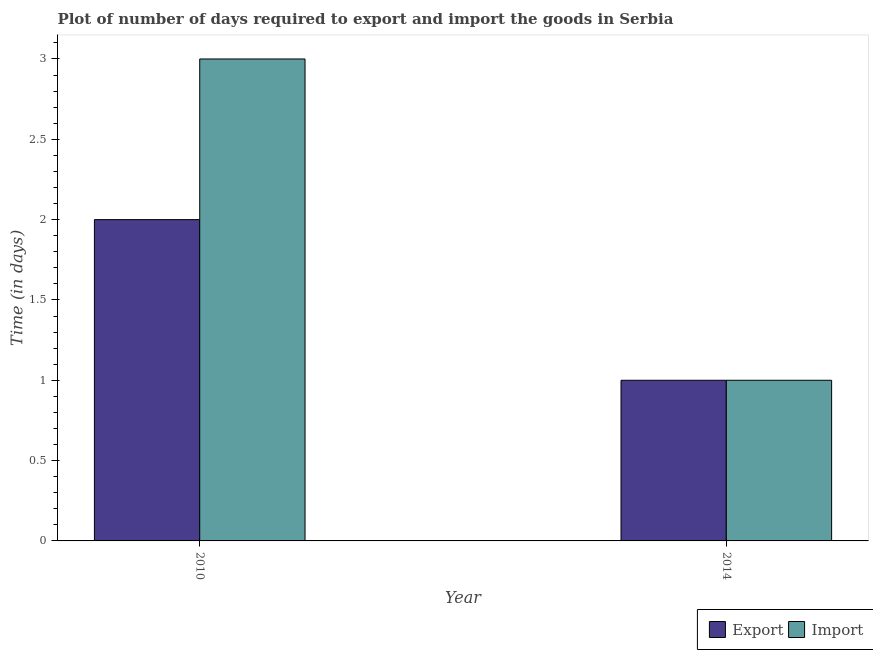How many different coloured bars are there?
Make the answer very short. 2. How many groups of bars are there?
Give a very brief answer. 2. Are the number of bars per tick equal to the number of legend labels?
Your response must be concise. Yes. What is the time required to import in 2014?
Offer a terse response. 1. Across all years, what is the maximum time required to import?
Provide a succinct answer. 3. Across all years, what is the minimum time required to export?
Ensure brevity in your answer.  1. In which year was the time required to export maximum?
Your answer should be very brief. 2010. What is the total time required to import in the graph?
Your answer should be very brief. 4. What is the difference between the time required to import in 2010 and that in 2014?
Keep it short and to the point. 2. What is the difference between the time required to import in 2014 and the time required to export in 2010?
Give a very brief answer. -2. What does the 1st bar from the left in 2010 represents?
Your answer should be compact. Export. What does the 2nd bar from the right in 2014 represents?
Provide a succinct answer. Export. Are all the bars in the graph horizontal?
Provide a succinct answer. No. How many years are there in the graph?
Keep it short and to the point. 2. What is the difference between two consecutive major ticks on the Y-axis?
Ensure brevity in your answer.  0.5. Does the graph contain grids?
Keep it short and to the point. No. What is the title of the graph?
Make the answer very short. Plot of number of days required to export and import the goods in Serbia. What is the label or title of the Y-axis?
Your response must be concise. Time (in days). What is the Time (in days) of Export in 2010?
Your answer should be compact. 2. What is the Time (in days) in Import in 2010?
Provide a short and direct response. 3. What is the Time (in days) of Import in 2014?
Keep it short and to the point. 1. Across all years, what is the maximum Time (in days) in Import?
Ensure brevity in your answer.  3. What is the total Time (in days) of Export in the graph?
Provide a succinct answer. 3. What is the difference between the Time (in days) of Import in 2010 and that in 2014?
Make the answer very short. 2. What is the difference between the Time (in days) in Export in 2010 and the Time (in days) in Import in 2014?
Ensure brevity in your answer.  1. In the year 2014, what is the difference between the Time (in days) in Export and Time (in days) in Import?
Ensure brevity in your answer.  0. What is the ratio of the Time (in days) in Import in 2010 to that in 2014?
Give a very brief answer. 3. What is the difference between the highest and the second highest Time (in days) of Export?
Your response must be concise. 1. What is the difference between the highest and the lowest Time (in days) of Import?
Offer a terse response. 2. 